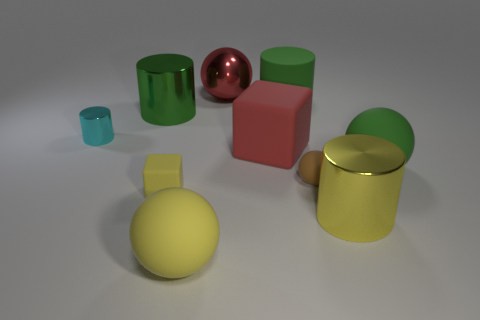The yellow object that is the same size as the yellow ball is what shape?
Your response must be concise. Cylinder. Is there a small brown thing of the same shape as the red metallic object?
Keep it short and to the point. Yes. Does the block right of the big yellow ball have the same material as the cyan object behind the large yellow matte thing?
Give a very brief answer. No. There is a metal thing that is the same color as the big rubber cylinder; what shape is it?
Your answer should be very brief. Cylinder. How many small yellow spheres are the same material as the big red ball?
Offer a terse response. 0. The small cylinder has what color?
Provide a succinct answer. Cyan. Does the big green rubber thing behind the small cyan cylinder have the same shape as the small object to the right of the yellow block?
Your response must be concise. No. What color is the sphere that is behind the red matte cube?
Offer a terse response. Red. Is the number of green cylinders in front of the green metal thing less than the number of blocks that are in front of the large red matte cube?
Offer a very short reply. Yes. What number of other things are there of the same material as the large green sphere
Keep it short and to the point. 5. 